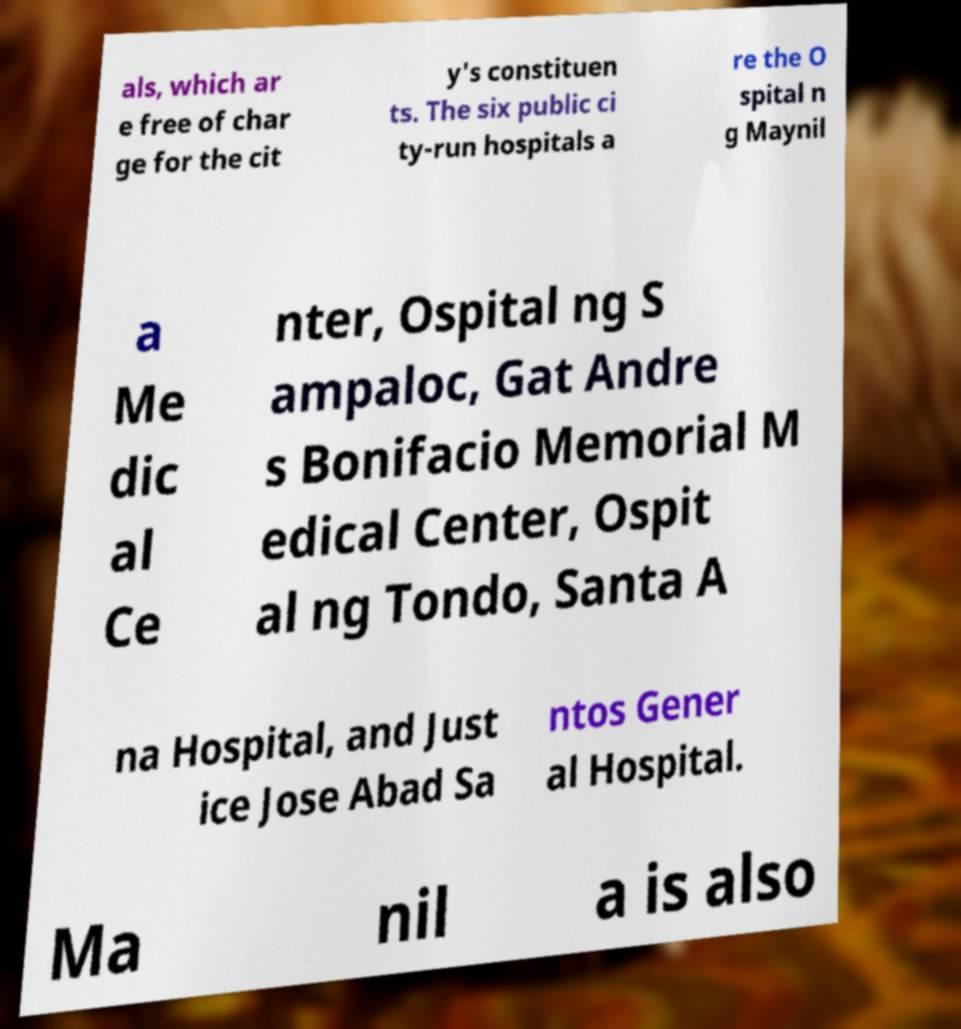What messages or text are displayed in this image? I need them in a readable, typed format. als, which ar e free of char ge for the cit y's constituen ts. The six public ci ty-run hospitals a re the O spital n g Maynil a Me dic al Ce nter, Ospital ng S ampaloc, Gat Andre s Bonifacio Memorial M edical Center, Ospit al ng Tondo, Santa A na Hospital, and Just ice Jose Abad Sa ntos Gener al Hospital. Ma nil a is also 